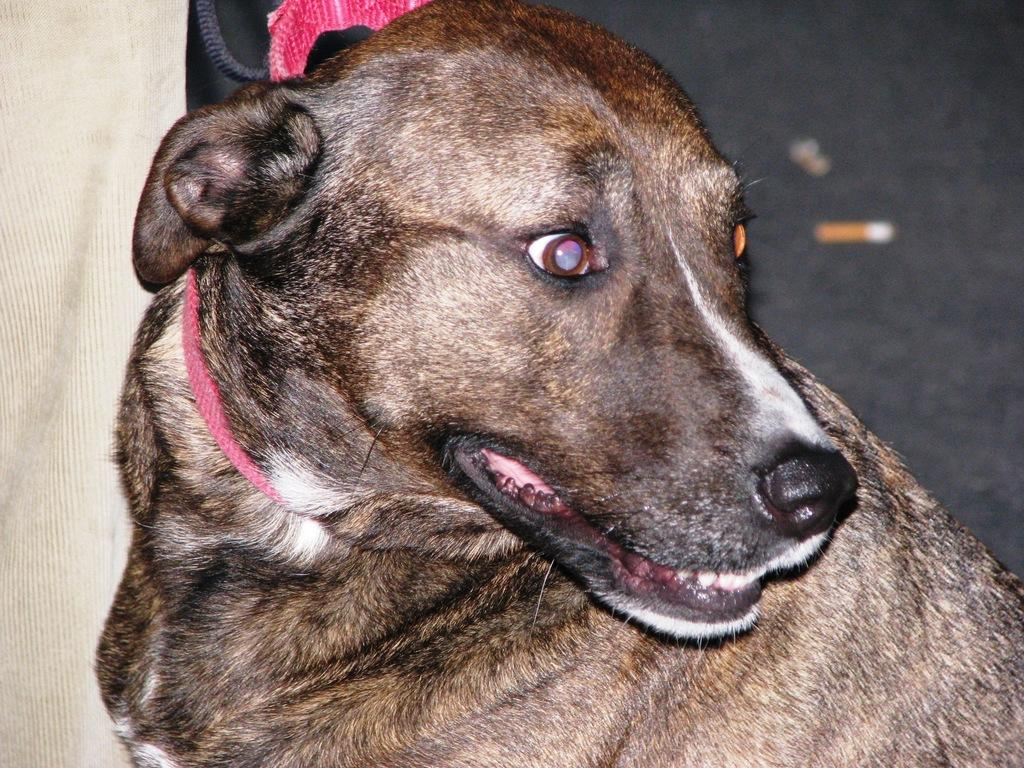What type of animal is present in the image? There is a dog in the image. Can you describe the background of the image? There is a cream-colored cloth in the background of the image. What type of religious expansion is depicted in the image? There is no religious expansion depicted in the image; it features a dog and a cream-colored cloth in the background. 